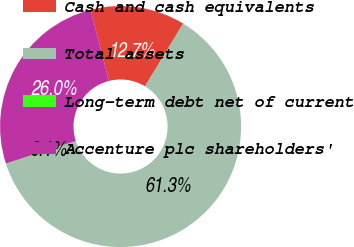Convert chart. <chart><loc_0><loc_0><loc_500><loc_500><pie_chart><fcel>Cash and cash equivalents<fcel>Total assets<fcel>Long-term debt net of current<fcel>Accenture plc shareholders'<nl><fcel>12.69%<fcel>61.28%<fcel>0.05%<fcel>25.98%<nl></chart> 